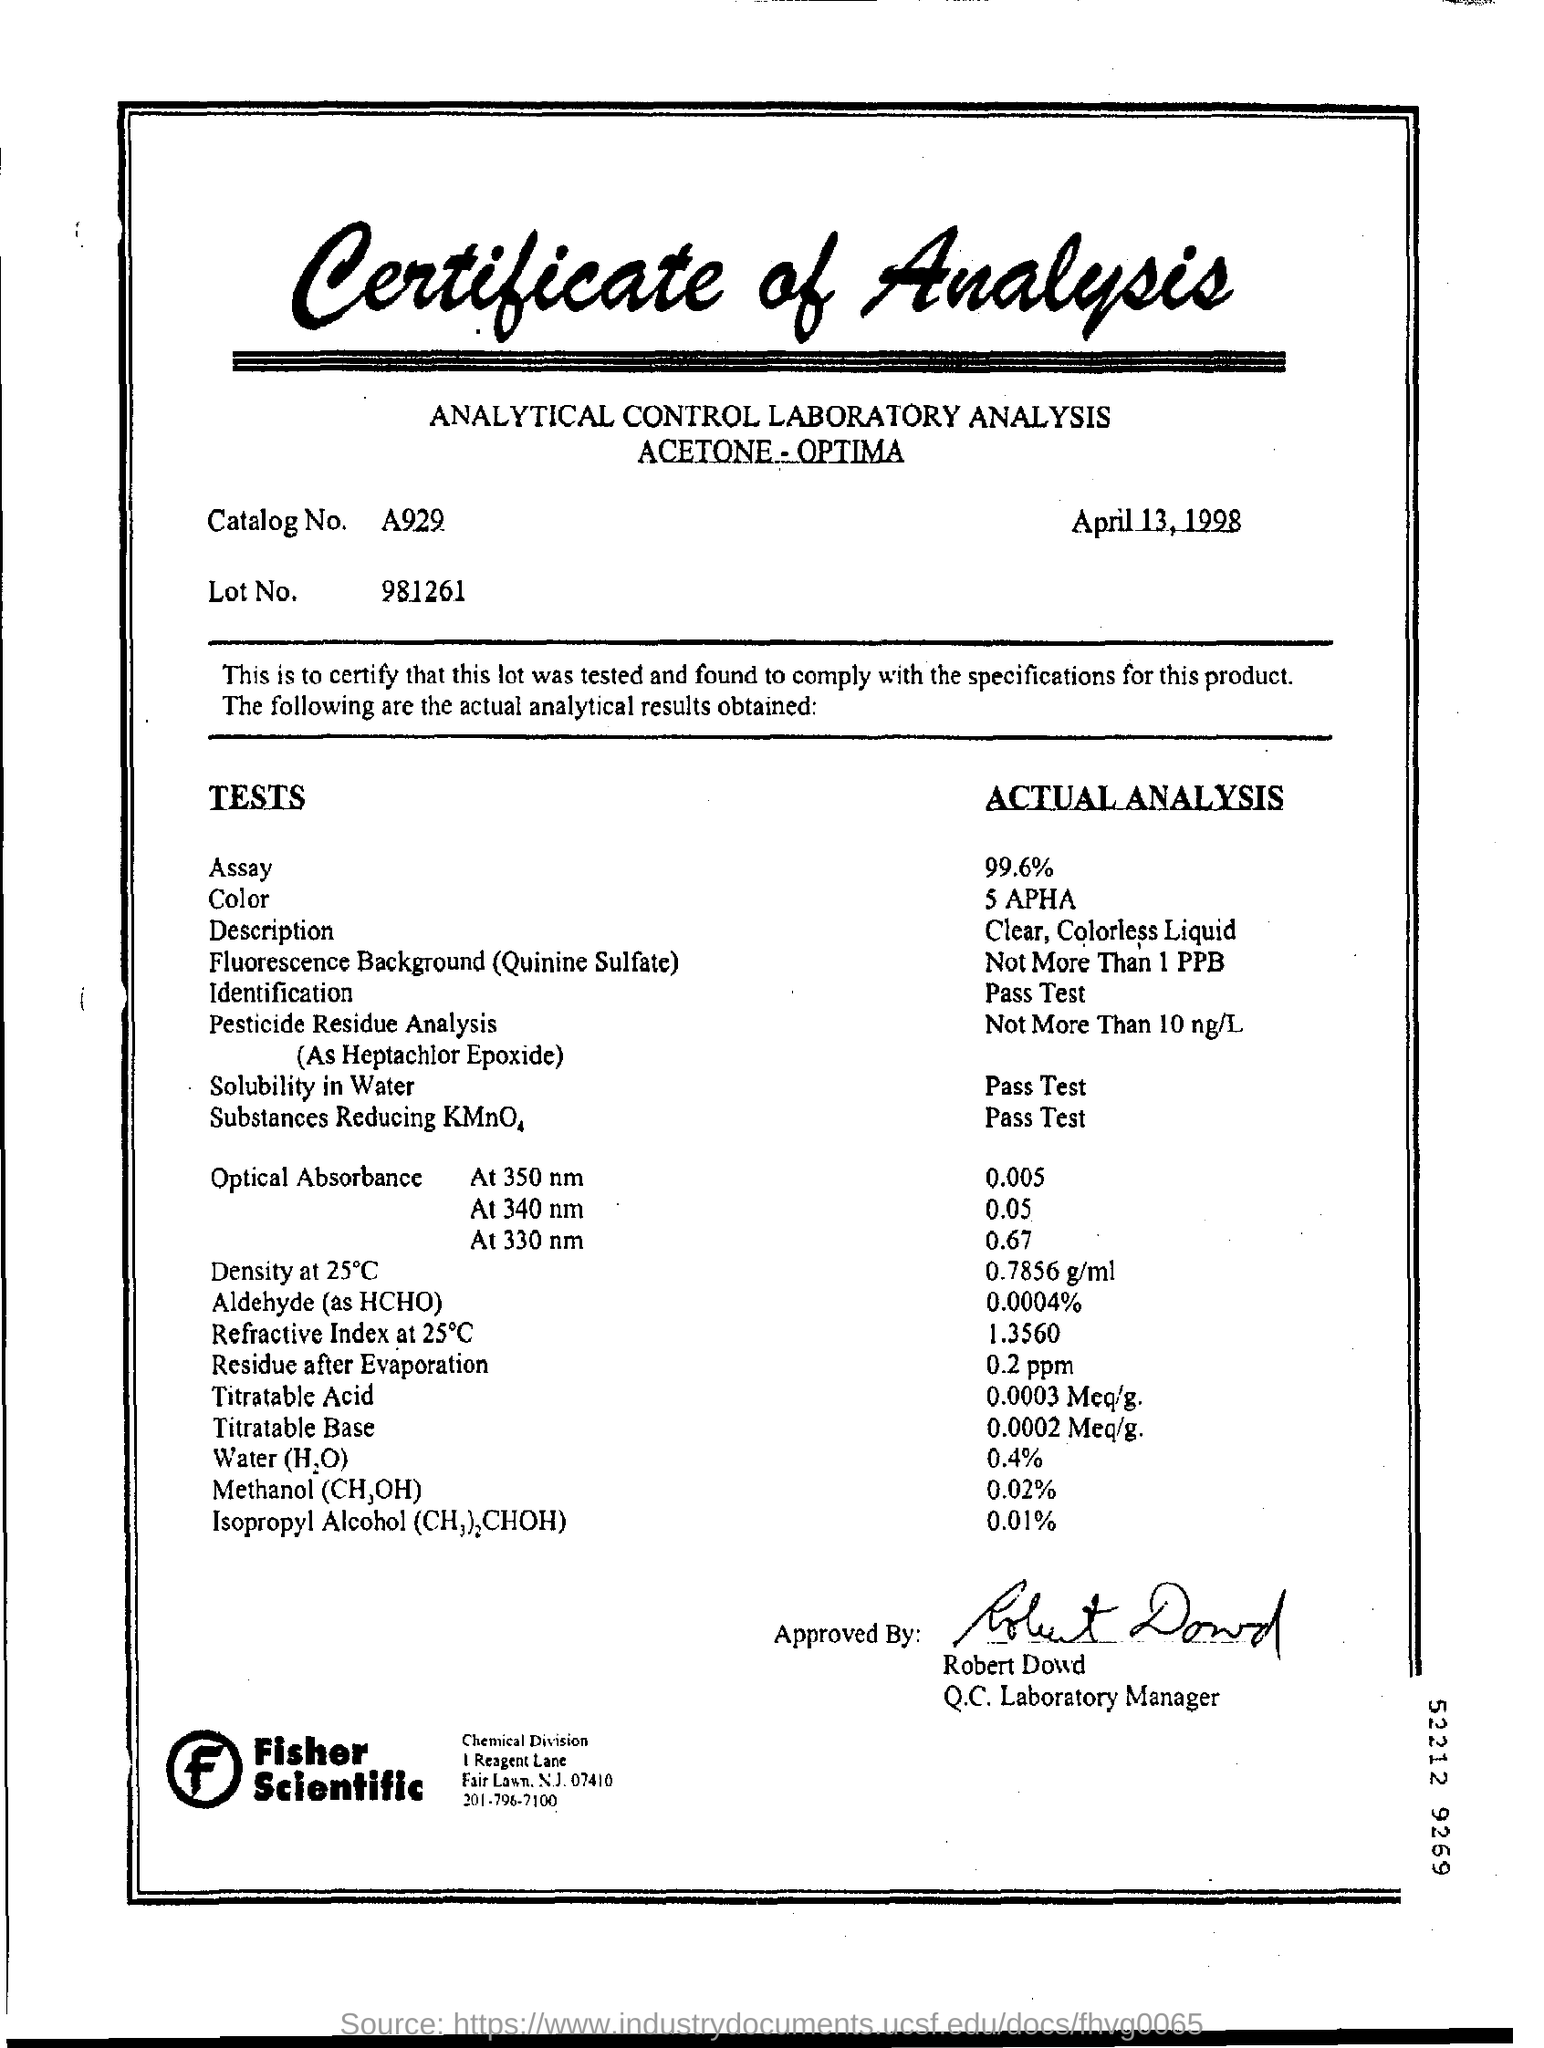What is the date on the document?
Provide a succinct answer. April 13, 1998. What is the Catalog No.?
Your answer should be compact. A929. What is the Lot No.?
Provide a succinct answer. 981261. What is the "Actual Analysis" for "Assay"?
Keep it short and to the point. 99.6%. What is the "Actual Analysis" for "Water (H2O)?"?
Your response must be concise. 0.4%. What is the "Actual Analysis" for "Residue After Evaporation"?
Ensure brevity in your answer.  0.2 ppm. What is the "Actual Analysis" for "Titratable Acid"?
Make the answer very short. 0.0003 Meq/g. What is the "Actual Analysis" for "Titratable Base"?
Ensure brevity in your answer.  0.0002 Meq/g. The Certificate is approved by whom?
Keep it short and to the point. Robert Dowd. What is the "Actual Analysis" for "Methanol (CH3OH)"?
Provide a succinct answer. 0.02%. 